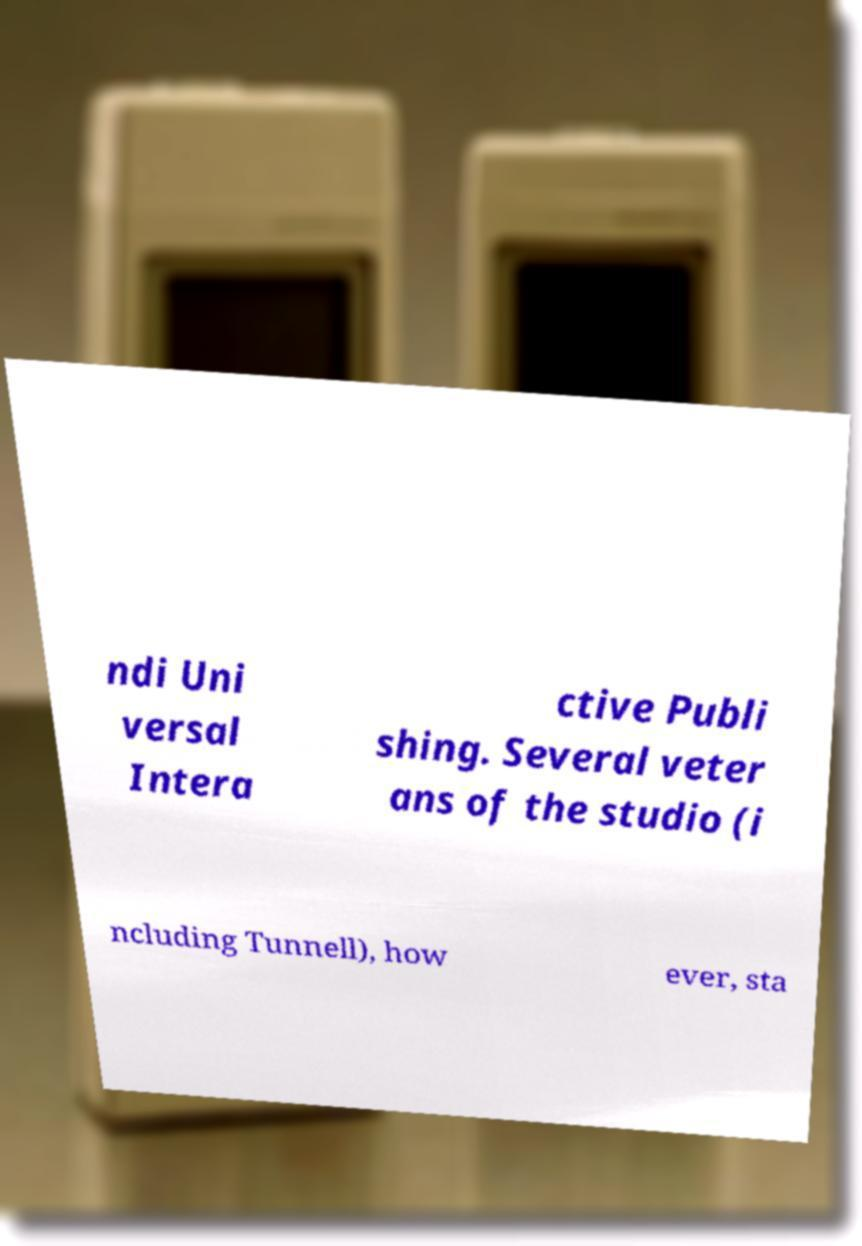For documentation purposes, I need the text within this image transcribed. Could you provide that? ndi Uni versal Intera ctive Publi shing. Several veter ans of the studio (i ncluding Tunnell), how ever, sta 